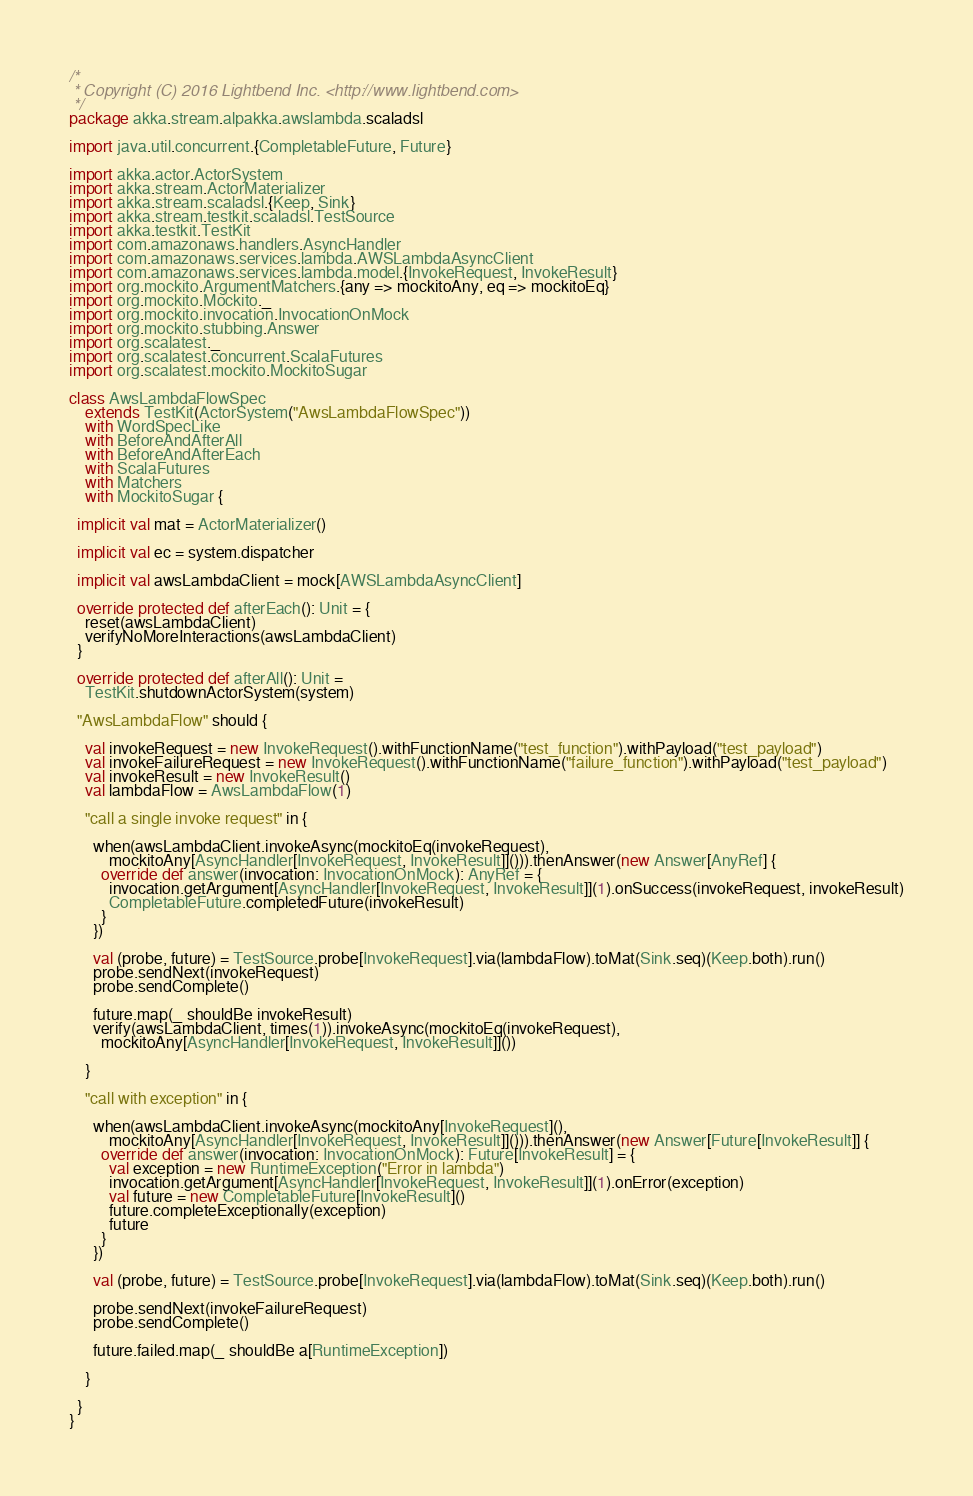Convert code to text. <code><loc_0><loc_0><loc_500><loc_500><_Scala_>/*
 * Copyright (C) 2016 Lightbend Inc. <http://www.lightbend.com>
 */
package akka.stream.alpakka.awslambda.scaladsl

import java.util.concurrent.{CompletableFuture, Future}

import akka.actor.ActorSystem
import akka.stream.ActorMaterializer
import akka.stream.scaladsl.{Keep, Sink}
import akka.stream.testkit.scaladsl.TestSource
import akka.testkit.TestKit
import com.amazonaws.handlers.AsyncHandler
import com.amazonaws.services.lambda.AWSLambdaAsyncClient
import com.amazonaws.services.lambda.model.{InvokeRequest, InvokeResult}
import org.mockito.ArgumentMatchers.{any => mockitoAny, eq => mockitoEq}
import org.mockito.Mockito._
import org.mockito.invocation.InvocationOnMock
import org.mockito.stubbing.Answer
import org.scalatest._
import org.scalatest.concurrent.ScalaFutures
import org.scalatest.mockito.MockitoSugar

class AwsLambdaFlowSpec
    extends TestKit(ActorSystem("AwsLambdaFlowSpec"))
    with WordSpecLike
    with BeforeAndAfterAll
    with BeforeAndAfterEach
    with ScalaFutures
    with Matchers
    with MockitoSugar {

  implicit val mat = ActorMaterializer()

  implicit val ec = system.dispatcher

  implicit val awsLambdaClient = mock[AWSLambdaAsyncClient]

  override protected def afterEach(): Unit = {
    reset(awsLambdaClient)
    verifyNoMoreInteractions(awsLambdaClient)
  }

  override protected def afterAll(): Unit =
    TestKit.shutdownActorSystem(system)

  "AwsLambdaFlow" should {

    val invokeRequest = new InvokeRequest().withFunctionName("test_function").withPayload("test_payload")
    val invokeFailureRequest = new InvokeRequest().withFunctionName("failure_function").withPayload("test_payload")
    val invokeResult = new InvokeResult()
    val lambdaFlow = AwsLambdaFlow(1)

    "call a single invoke request" in {

      when(awsLambdaClient.invokeAsync(mockitoEq(invokeRequest),
          mockitoAny[AsyncHandler[InvokeRequest, InvokeResult]]())).thenAnswer(new Answer[AnyRef] {
        override def answer(invocation: InvocationOnMock): AnyRef = {
          invocation.getArgument[AsyncHandler[InvokeRequest, InvokeResult]](1).onSuccess(invokeRequest, invokeResult)
          CompletableFuture.completedFuture(invokeResult)
        }
      })

      val (probe, future) = TestSource.probe[InvokeRequest].via(lambdaFlow).toMat(Sink.seq)(Keep.both).run()
      probe.sendNext(invokeRequest)
      probe.sendComplete()

      future.map(_ shouldBe invokeResult)
      verify(awsLambdaClient, times(1)).invokeAsync(mockitoEq(invokeRequest),
        mockitoAny[AsyncHandler[InvokeRequest, InvokeResult]]())

    }

    "call with exception" in {

      when(awsLambdaClient.invokeAsync(mockitoAny[InvokeRequest](),
          mockitoAny[AsyncHandler[InvokeRequest, InvokeResult]]())).thenAnswer(new Answer[Future[InvokeResult]] {
        override def answer(invocation: InvocationOnMock): Future[InvokeResult] = {
          val exception = new RuntimeException("Error in lambda")
          invocation.getArgument[AsyncHandler[InvokeRequest, InvokeResult]](1).onError(exception)
          val future = new CompletableFuture[InvokeResult]()
          future.completeExceptionally(exception)
          future
        }
      })

      val (probe, future) = TestSource.probe[InvokeRequest].via(lambdaFlow).toMat(Sink.seq)(Keep.both).run()

      probe.sendNext(invokeFailureRequest)
      probe.sendComplete()

      future.failed.map(_ shouldBe a[RuntimeException])

    }

  }
}
</code> 